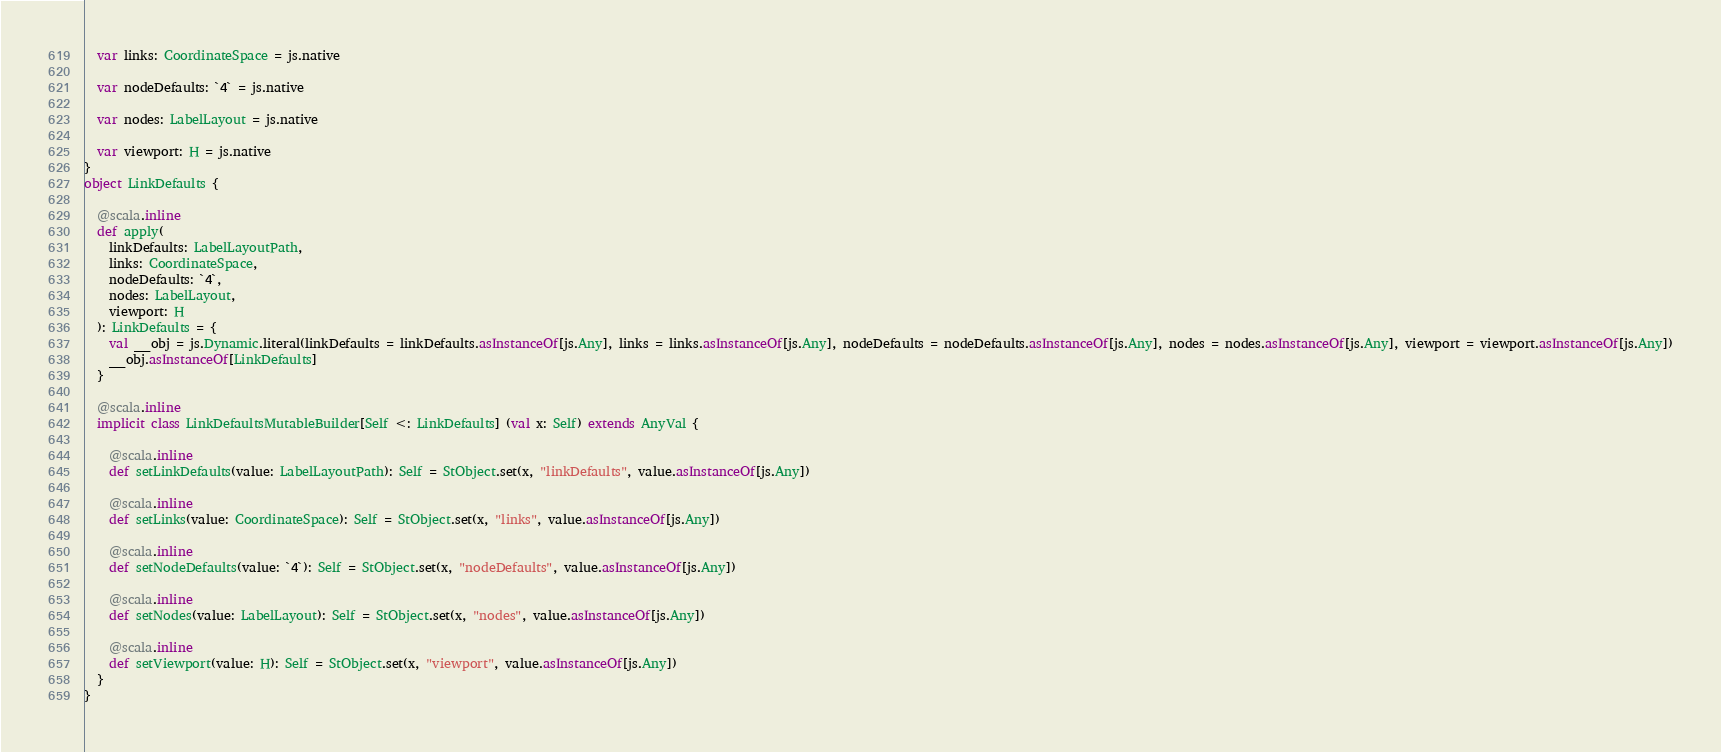Convert code to text. <code><loc_0><loc_0><loc_500><loc_500><_Scala_>  var links: CoordinateSpace = js.native
  
  var nodeDefaults: `4` = js.native
  
  var nodes: LabelLayout = js.native
  
  var viewport: H = js.native
}
object LinkDefaults {
  
  @scala.inline
  def apply(
    linkDefaults: LabelLayoutPath,
    links: CoordinateSpace,
    nodeDefaults: `4`,
    nodes: LabelLayout,
    viewport: H
  ): LinkDefaults = {
    val __obj = js.Dynamic.literal(linkDefaults = linkDefaults.asInstanceOf[js.Any], links = links.asInstanceOf[js.Any], nodeDefaults = nodeDefaults.asInstanceOf[js.Any], nodes = nodes.asInstanceOf[js.Any], viewport = viewport.asInstanceOf[js.Any])
    __obj.asInstanceOf[LinkDefaults]
  }
  
  @scala.inline
  implicit class LinkDefaultsMutableBuilder[Self <: LinkDefaults] (val x: Self) extends AnyVal {
    
    @scala.inline
    def setLinkDefaults(value: LabelLayoutPath): Self = StObject.set(x, "linkDefaults", value.asInstanceOf[js.Any])
    
    @scala.inline
    def setLinks(value: CoordinateSpace): Self = StObject.set(x, "links", value.asInstanceOf[js.Any])
    
    @scala.inline
    def setNodeDefaults(value: `4`): Self = StObject.set(x, "nodeDefaults", value.asInstanceOf[js.Any])
    
    @scala.inline
    def setNodes(value: LabelLayout): Self = StObject.set(x, "nodes", value.asInstanceOf[js.Any])
    
    @scala.inline
    def setViewport(value: H): Self = StObject.set(x, "viewport", value.asInstanceOf[js.Any])
  }
}
</code> 